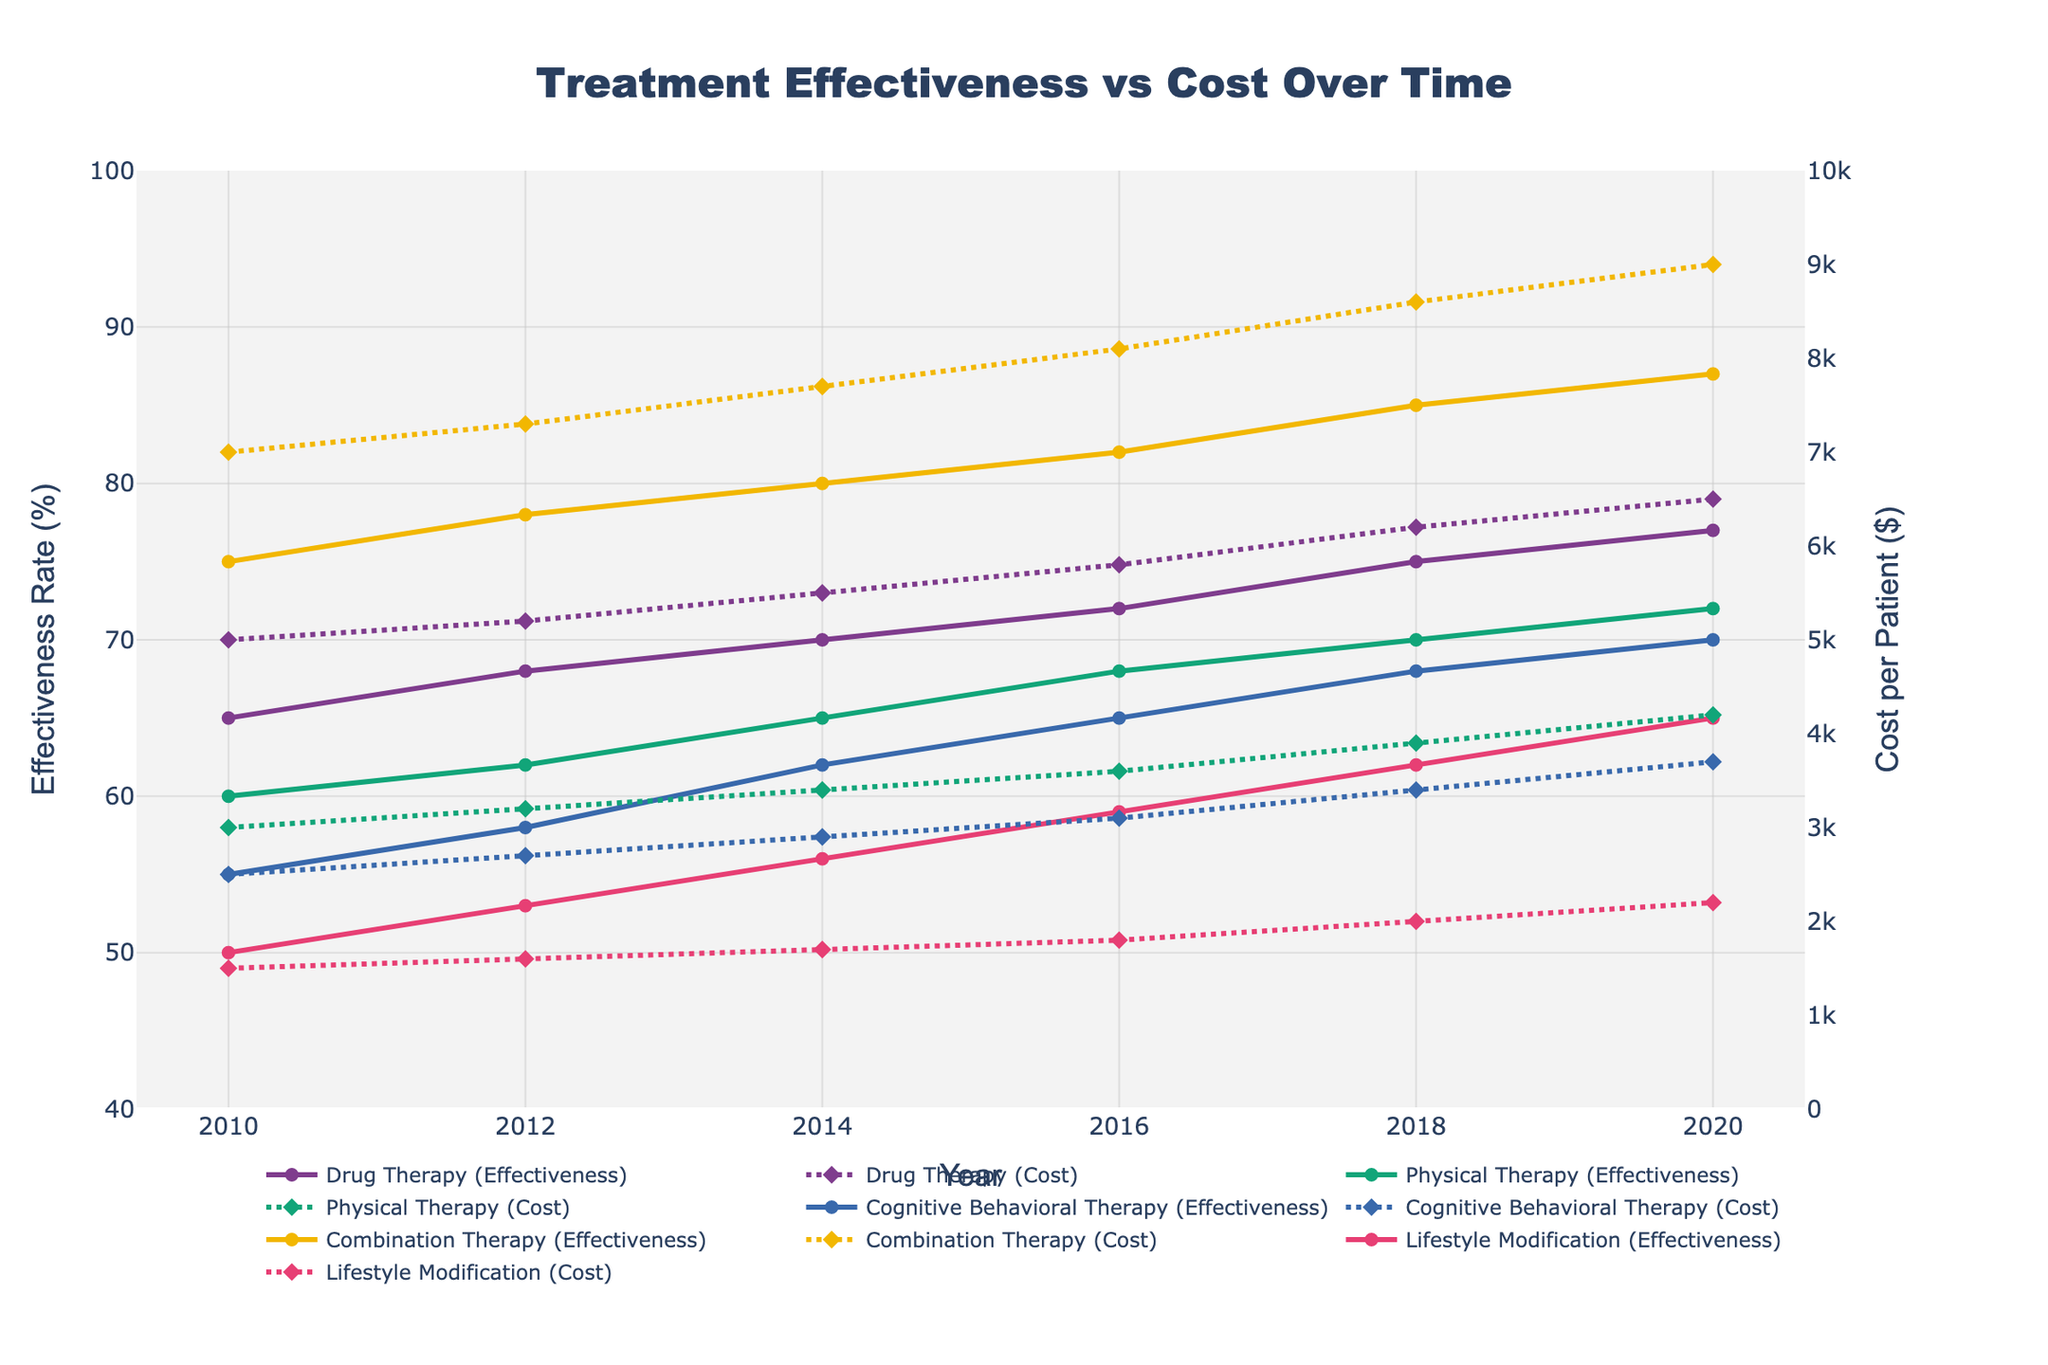What treatment method had the highest effectiveness rate in 2020? Identify the effectiveness rates for all treatments in 2020 and find the maximum value. Combination Therapy had the highest effectiveness rate at 87%.
Answer: Combination Therapy How did the effectiveness rate of Physical Therapy change from 2010 to 2020? Subtract the effectiveness rate of Physical Therapy in 2010 from the effectiveness rate in 2020: 72 - 60 = 12%.
Answer: Increased by 12% Compare the cost per patient for Drug Therapy and Cognitive Behavioral Therapy in 2014. Which one is lower? Check the cost per patient for both treatments in 2014. Drug Therapy costs $5500 while Cognitive Behavioral Therapy costs $2900. Cognitive Behavioral Therapy is lower.
Answer: Cognitive Behavioral Therapy Which treatment method had the lowest cost per patient throughout the entire period? Compare the costs per patient for all treatments from 2010 to 2020 and find the minimum. Lifestyle Modification had the lowest cost at $1500 in 2010.
Answer: Lifestyle Modification Was there any year where the cost of Physical Therapy was equal to or higher than Drug Therapy? Compare the cost per patient for Physical Therapy and Drug Therapy for each year 2010-2020. Physical Therapy never reaches or exceeds Drug Therapy cost in any year.
Answer: No Calculate the total increase in cost per patient for Combination Therapy from 2010 to 2020. Subtract the 2010 cost from the 2020 cost for Combination Therapy: 9000 - 7000 = 2000.
Answer: $2000 Which treatment method showed the most consistent increase in effectiveness rate over the years? Observe the lines for effectiveness rates and identify the one with the most steady growth. Lifestyle Modification consistently increased from 50% to 65% without any drop or plateau.
Answer: Lifestyle Modification Compare the effectiveness rates of all treatments in 2016. Which treatment had the lowest rate? Check the effectiveness rates for all treatments in 2016. Lifestyle Modification had the lowest rate at 59%.
Answer: Lifestyle Modification How much more effective is Combination Therapy compared to Cognitive Behavioral Therapy in 2020? Subtract the effectiveness rate of Cognitive Behavioral Therapy from Combination Therapy in 2020: 87 - 70 = 17%.
Answer: 17% 